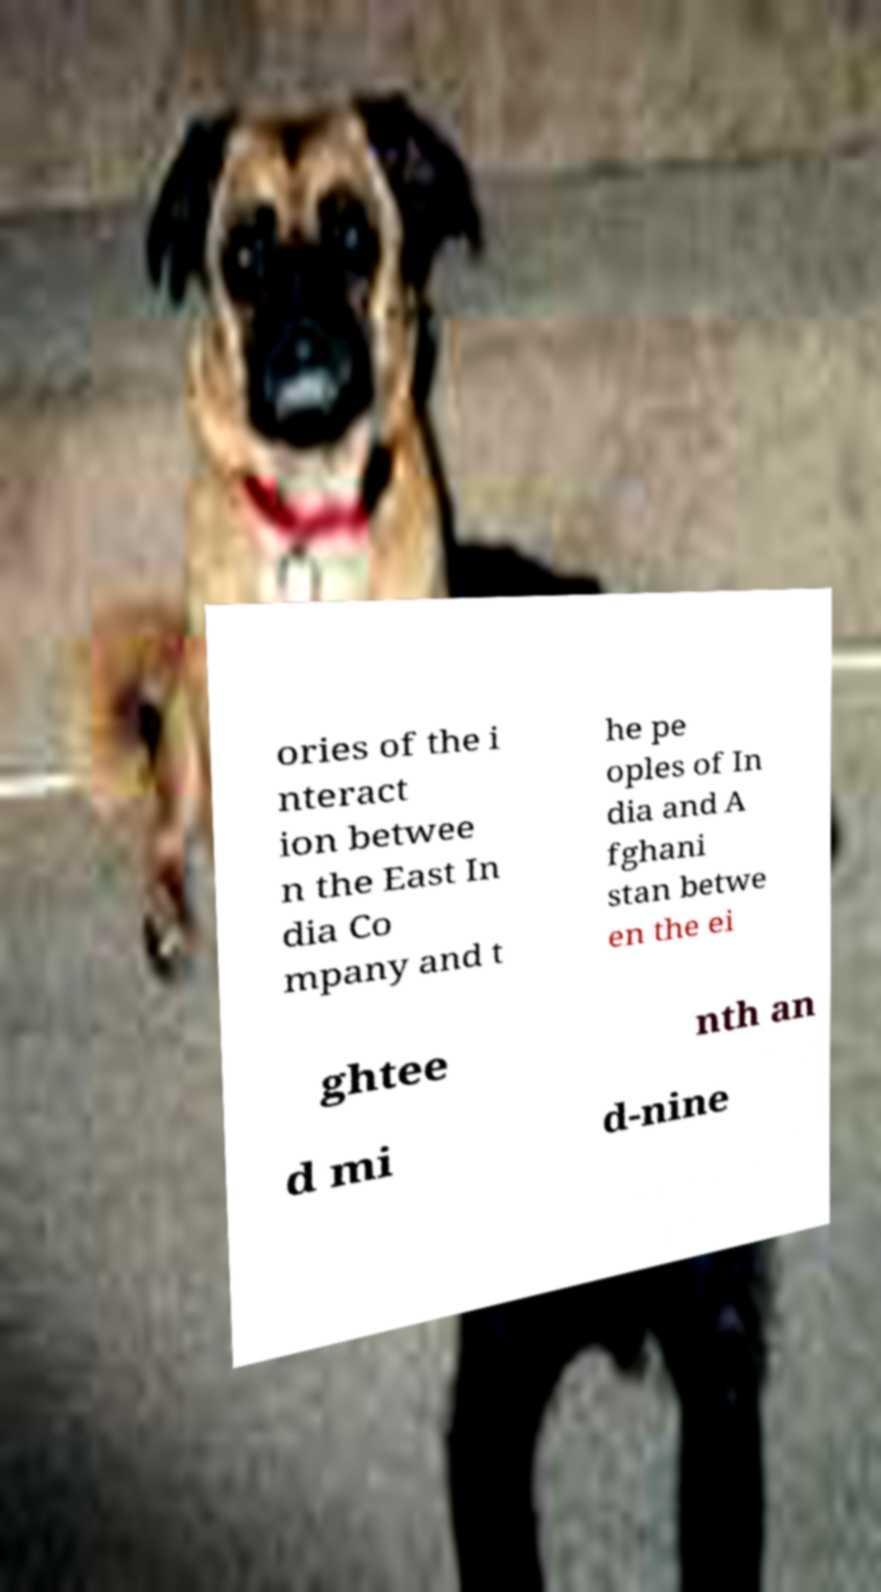Could you extract and type out the text from this image? ories of the i nteract ion betwee n the East In dia Co mpany and t he pe oples of In dia and A fghani stan betwe en the ei ghtee nth an d mi d-nine 